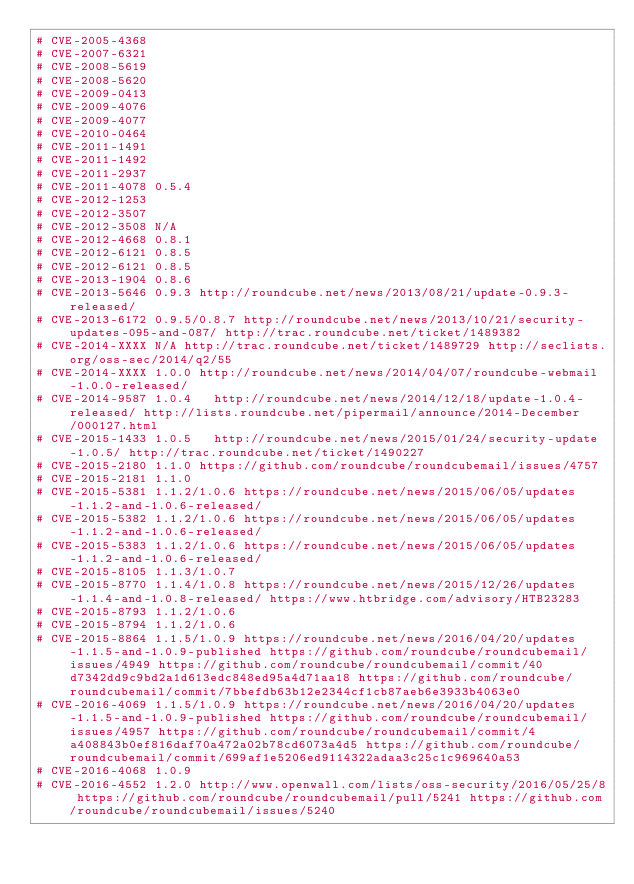Convert code to text. <code><loc_0><loc_0><loc_500><loc_500><_YAML_># CVE-2005-4368
# CVE-2007-6321
# CVE-2008-5619
# CVE-2008-5620
# CVE-2009-0413
# CVE-2009-4076
# CVE-2009-4077
# CVE-2010-0464
# CVE-2011-1491
# CVE-2011-1492
# CVE-2011-2937
# CVE-2011-4078 0.5.4
# CVE-2012-1253
# CVE-2012-3507
# CVE-2012-3508 N/A
# CVE-2012-4668 0.8.1
# CVE-2012-6121 0.8.5
# CVE-2012-6121 0.8.5
# CVE-2013-1904 0.8.6
# CVE-2013-5646 0.9.3 http://roundcube.net/news/2013/08/21/update-0.9.3-released/
# CVE-2013-6172 0.9.5/0.8.7 http://roundcube.net/news/2013/10/21/security-updates-095-and-087/ http://trac.roundcube.net/ticket/1489382
# CVE-2014-XXXX N/A http://trac.roundcube.net/ticket/1489729 http://seclists.org/oss-sec/2014/q2/55
# CVE-2014-XXXX 1.0.0 http://roundcube.net/news/2014/04/07/roundcube-webmail-1.0.0-released/
# CVE-2014-9587 1.0.4   http://roundcube.net/news/2014/12/18/update-1.0.4-released/ http://lists.roundcube.net/pipermail/announce/2014-December/000127.html
# CVE-2015-1433 1.0.5   http://roundcube.net/news/2015/01/24/security-update-1.0.5/ http://trac.roundcube.net/ticket/1490227
# CVE-2015-2180 1.1.0 https://github.com/roundcube/roundcubemail/issues/4757
# CVE-2015-2181 1.1.0
# CVE-2015-5381 1.1.2/1.0.6 https://roundcube.net/news/2015/06/05/updates-1.1.2-and-1.0.6-released/
# CVE-2015-5382 1.1.2/1.0.6 https://roundcube.net/news/2015/06/05/updates-1.1.2-and-1.0.6-released/
# CVE-2015-5383 1.1.2/1.0.6 https://roundcube.net/news/2015/06/05/updates-1.1.2-and-1.0.6-released/
# CVE-2015-8105 1.1.3/1.0.7
# CVE-2015-8770 1.1.4/1.0.8 https://roundcube.net/news/2015/12/26/updates-1.1.4-and-1.0.8-released/ https://www.htbridge.com/advisory/HTB23283
# CVE-2015-8793 1.1.2/1.0.6
# CVE-2015-8794 1.1.2/1.0.6
# CVE-2015-8864 1.1.5/1.0.9 https://roundcube.net/news/2016/04/20/updates-1.1.5-and-1.0.9-published https://github.com/roundcube/roundcubemail/issues/4949 https://github.com/roundcube/roundcubemail/commit/40d7342dd9c9bd2a1d613edc848ed95a4d71aa18 https://github.com/roundcube/roundcubemail/commit/7bbefdb63b12e2344cf1cb87aeb6e3933b4063e0
# CVE-2016-4069 1.1.5/1.0.9 https://roundcube.net/news/2016/04/20/updates-1.1.5-and-1.0.9-published https://github.com/roundcube/roundcubemail/issues/4957 https://github.com/roundcube/roundcubemail/commit/4a408843b0ef816daf70a472a02b78cd6073a4d5 https://github.com/roundcube/roundcubemail/commit/699af1e5206ed9114322adaa3c25c1c969640a53
# CVE-2016-4068 1.0.9
# CVE-2016-4552 1.2.0 http://www.openwall.com/lists/oss-security/2016/05/25/8 https://github.com/roundcube/roundcubemail/pull/5241 https://github.com/roundcube/roundcubemail/issues/5240</code> 